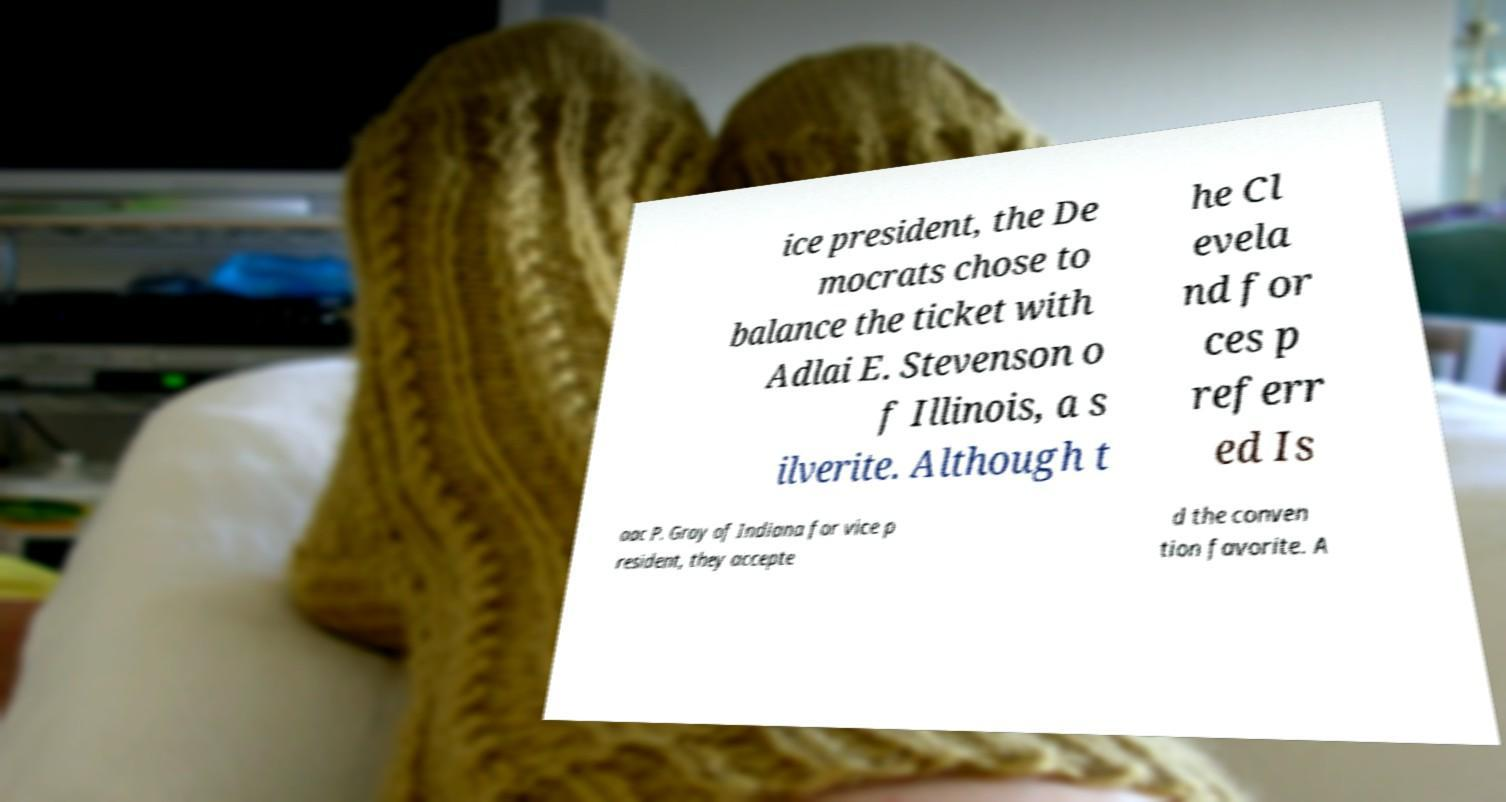Can you read and provide the text displayed in the image?This photo seems to have some interesting text. Can you extract and type it out for me? ice president, the De mocrats chose to balance the ticket with Adlai E. Stevenson o f Illinois, a s ilverite. Although t he Cl evela nd for ces p referr ed Is aac P. Gray of Indiana for vice p resident, they accepte d the conven tion favorite. A 